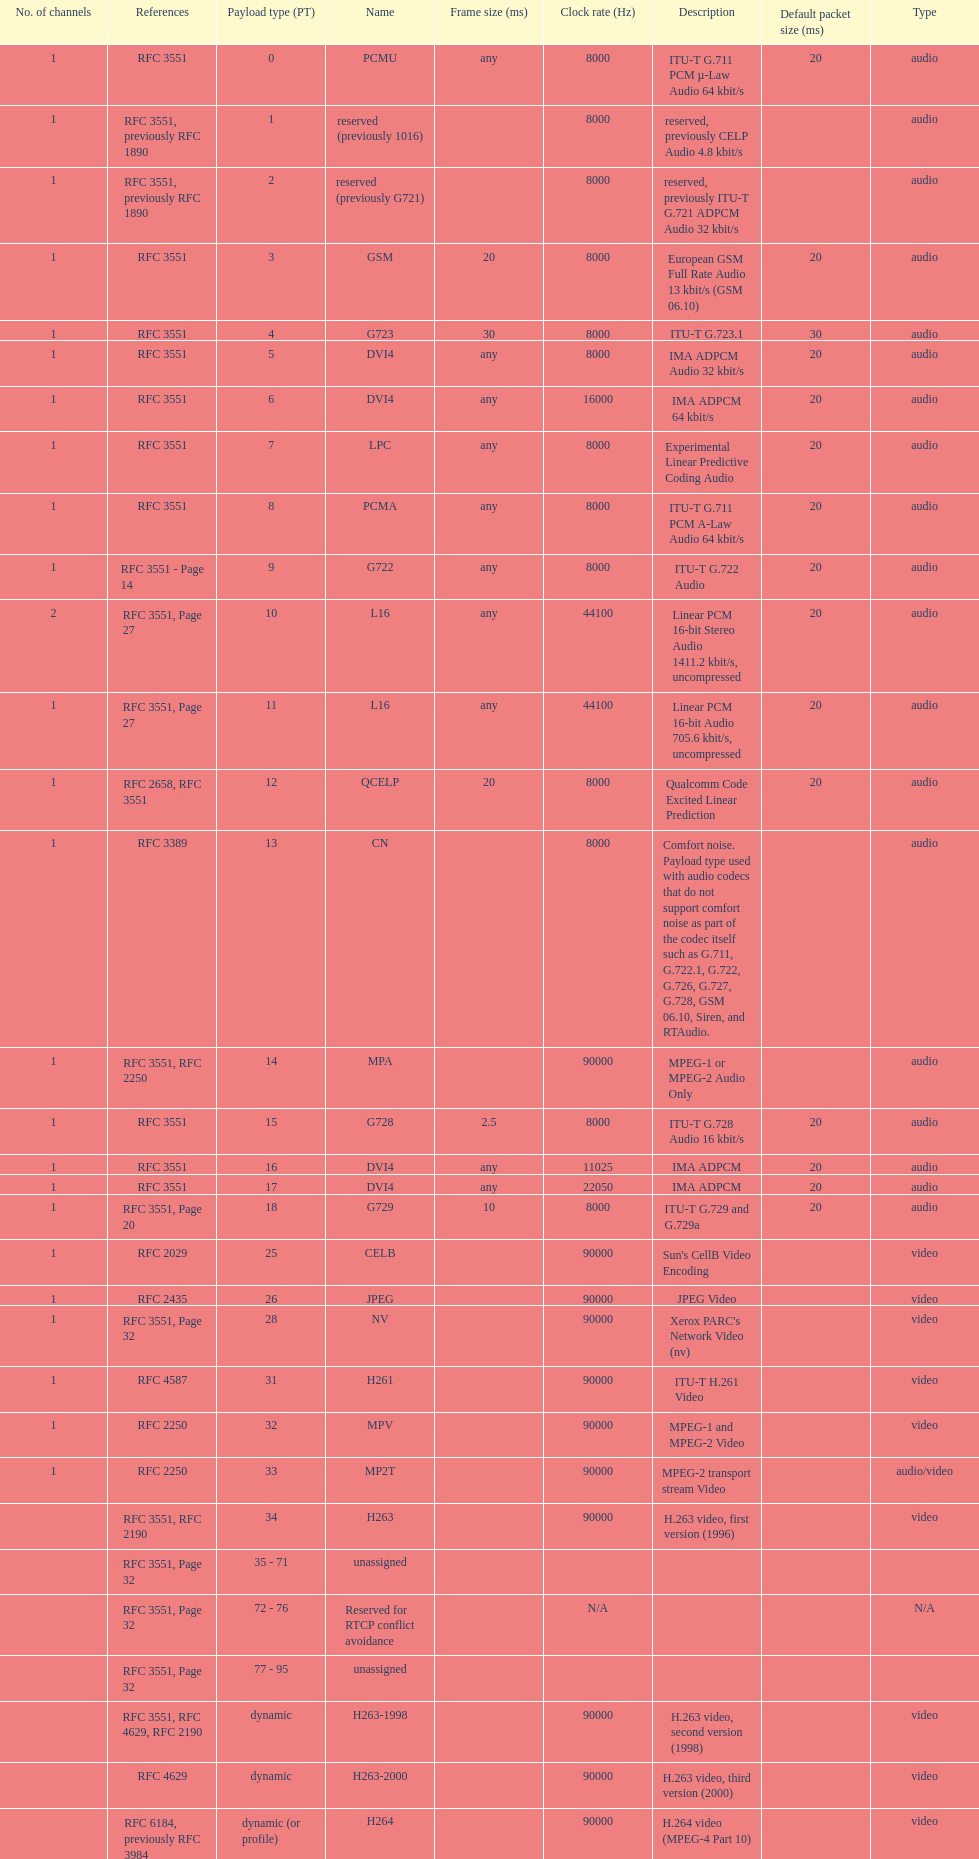The rtp/avp audio and video payload types include an audio type called qcelp and its frame size is how many ms? 20. 